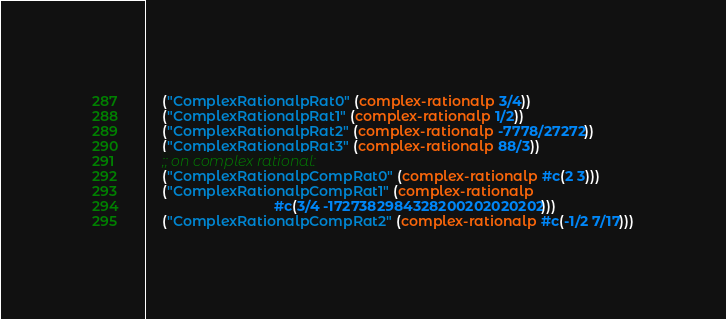<code> <loc_0><loc_0><loc_500><loc_500><_Lisp_>    ("ComplexRationalpRat0" (complex-rationalp 3/4))
    ("ComplexRationalpRat1" (complex-rationalp 1/2))
    ("ComplexRationalpRat2" (complex-rationalp -7778/27272))
    ("ComplexRationalpRat3" (complex-rationalp 88/3))
    ;; on complex rational:
    ("ComplexRationalpCompRat0" (complex-rationalp #c(2 3)))
    ("ComplexRationalpCompRat1" (complex-rationalp
                                 #c(3/4 -1727382984328200202020202)))
    ("ComplexRationalpCompRat2" (complex-rationalp #c(-1/2 7/17)))</code> 